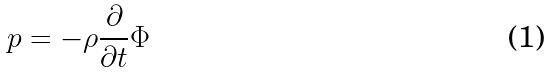Convert formula to latex. <formula><loc_0><loc_0><loc_500><loc_500>p = - \rho \frac { \partial } { \partial t } \Phi</formula> 